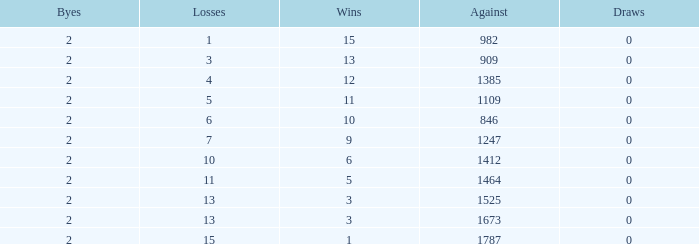What is the highest number listed under against when there were less than 3 wins and less than 15 losses? None. 